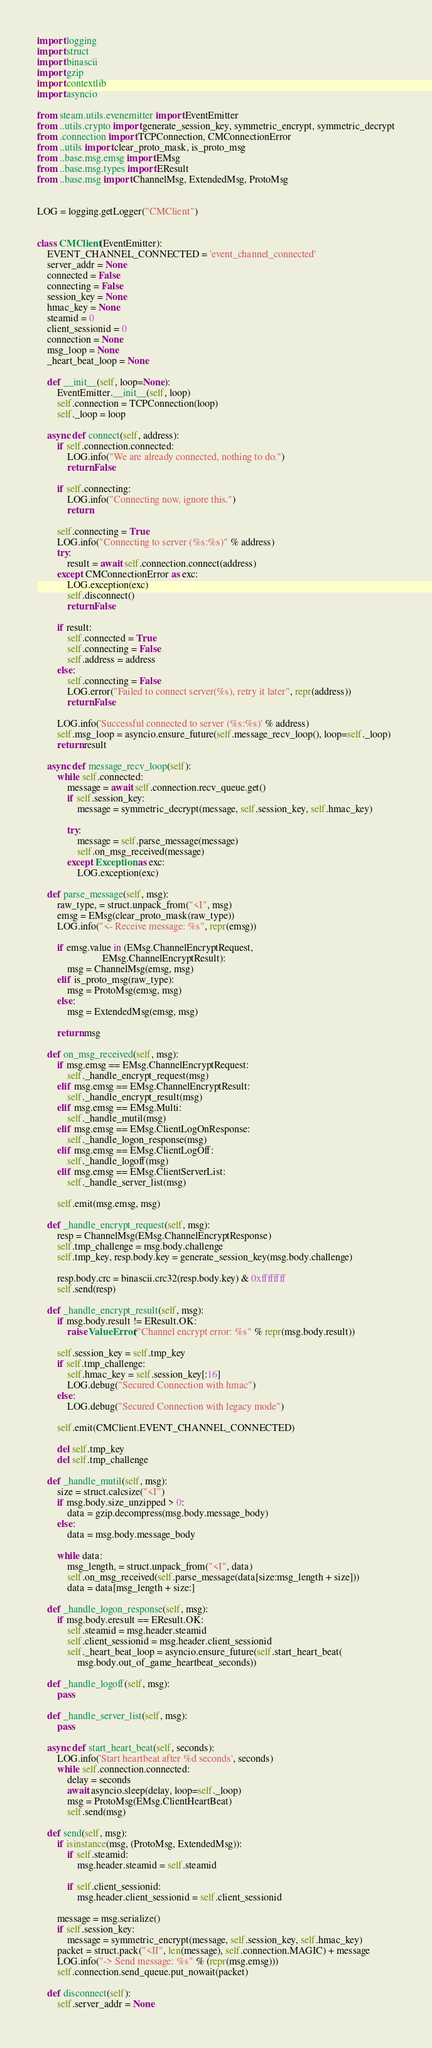<code> <loc_0><loc_0><loc_500><loc_500><_Python_>import logging
import struct
import binascii
import gzip
import contextlib
import asyncio

from steam.utils.evenemitter import EventEmitter
from ..utils.crypto import generate_session_key, symmetric_encrypt, symmetric_decrypt
from .connection import TCPConnection, CMConnectionError
from ..utils import clear_proto_mask, is_proto_msg
from ..base.msg.emsg import EMsg
from ..base.msg.types import EResult
from ..base.msg import ChannelMsg, ExtendedMsg, ProtoMsg


LOG = logging.getLogger("CMClient")


class CMClient(EventEmitter):
    EVENT_CHANNEL_CONNECTED = 'event_channel_connected'
    server_addr = None
    connected = False
    connecting = False
    session_key = None
    hmac_key = None
    steamid = 0
    client_sessionid = 0
    connection = None
    msg_loop = None
    _heart_beat_loop = None

    def __init__(self, loop=None):
        EventEmitter.__init__(self, loop)
        self.connection = TCPConnection(loop)
        self._loop = loop

    async def connect(self, address):
        if self.connection.connected:
            LOG.info("We are already connected, nothing to do.")
            return False

        if self.connecting:
            LOG.info("Connecting now, ignore this.")
            return

        self.connecting = True
        LOG.info("Connecting to server (%s:%s)" % address)
        try:
            result = await self.connection.connect(address)
        except CMConnectionError as exc:
            LOG.exception(exc)
            self.disconnect()
            return False

        if result:
            self.connected = True
            self.connecting = False
            self.address = address
        else:
            self.connecting = False
            LOG.error("Failed to connect server(%s), retry it later", repr(address))
            return False

        LOG.info('Successful connected to server (%s:%s)' % address)
        self.msg_loop = asyncio.ensure_future(self.message_recv_loop(), loop=self._loop)
        return result

    async def message_recv_loop(self):
        while self.connected:
            message = await self.connection.recv_queue.get()
            if self.session_key:
                message = symmetric_decrypt(message, self.session_key, self.hmac_key)

            try:
                message = self.parse_message(message)
                self.on_msg_received(message)
            except Exception as exc:
                LOG.exception(exc)

    def parse_message(self, msg):
        raw_type, = struct.unpack_from("<I", msg)
        emsg = EMsg(clear_proto_mask(raw_type))
        LOG.info("<- Receive message: %s", repr(emsg))

        if emsg.value in (EMsg.ChannelEncryptRequest,
                          EMsg.ChannelEncryptResult):
            msg = ChannelMsg(emsg, msg)
        elif is_proto_msg(raw_type):
            msg = ProtoMsg(emsg, msg)
        else:
            msg = ExtendedMsg(emsg, msg)

        return msg

    def on_msg_received(self, msg):
        if msg.emsg == EMsg.ChannelEncryptRequest:
            self._handle_encrypt_request(msg)
        elif msg.emsg == EMsg.ChannelEncryptResult:
            self._handle_encrypt_result(msg)
        elif msg.emsg == EMsg.Multi:
            self._handle_mutil(msg)
        elif msg.emsg == EMsg.ClientLogOnResponse:
            self._handle_logon_response(msg)
        elif msg.emsg == EMsg.ClientLogOff:
            self._handle_logoff(msg)
        elif msg.emsg == EMsg.ClientServerList:
            self._handle_server_list(msg)

        self.emit(msg.emsg, msg)

    def _handle_encrypt_request(self, msg):
        resp = ChannelMsg(EMsg.ChannelEncryptResponse)
        self.tmp_challenge = msg.body.challenge
        self.tmp_key, resp.body.key = generate_session_key(msg.body.challenge)

        resp.body.crc = binascii.crc32(resp.body.key) & 0xffffffff
        self.send(resp)

    def _handle_encrypt_result(self, msg):
        if msg.body.result != EResult.OK:
            raise ValueError("Channel encrypt error: %s" % repr(msg.body.result))

        self.session_key = self.tmp_key
        if self.tmp_challenge:
            self.hmac_key = self.session_key[:16]
            LOG.debug("Secured Connection with hmac")
        else:
            LOG.debug("Secured Connection with legacy mode")

        self.emit(CMClient.EVENT_CHANNEL_CONNECTED)

        del self.tmp_key
        del self.tmp_challenge

    def _handle_mutil(self, msg):
        size = struct.calcsize("<I")
        if msg.body.size_unzipped > 0:
            data = gzip.decompress(msg.body.message_body)
        else:
            data = msg.body.message_body

        while data:
            msg_length, = struct.unpack_from("<I", data)
            self.on_msg_received(self.parse_message(data[size:msg_length + size]))
            data = data[msg_length + size:]

    def _handle_logon_response(self, msg):
        if msg.body.eresult == EResult.OK:
            self.steamid = msg.header.steamid
            self.client_sessionid = msg.header.client_sessionid
            self._heart_beat_loop = asyncio.ensure_future(self.start_heart_beat(
                msg.body.out_of_game_heartbeat_seconds))

    def _handle_logoff(self, msg):
        pass

    def _handle_server_list(self, msg):
        pass

    async def start_heart_beat(self, seconds):
        LOG.info('Start heartbeat after %d seconds', seconds)
        while self.connection.connected:
            delay = seconds
            await asyncio.sleep(delay, loop=self._loop)
            msg = ProtoMsg(EMsg.ClientHeartBeat)
            self.send(msg)

    def send(self, msg):
        if isinstance(msg, (ProtoMsg, ExtendedMsg)):
            if self.steamid:
                msg.header.steamid = self.steamid

            if self.client_sessionid:
                msg.header.client_sessionid = self.client_sessionid

        message = msg.serialize()
        if self.session_key:
            message = symmetric_encrypt(message, self.session_key, self.hmac_key)
        packet = struct.pack("<II", len(message), self.connection.MAGIC) + message
        LOG.info("-> Send message: %s" % (repr(msg.emsg)))
        self.connection.send_queue.put_nowait(packet)

    def disconnect(self):
        self.server_addr = None</code> 